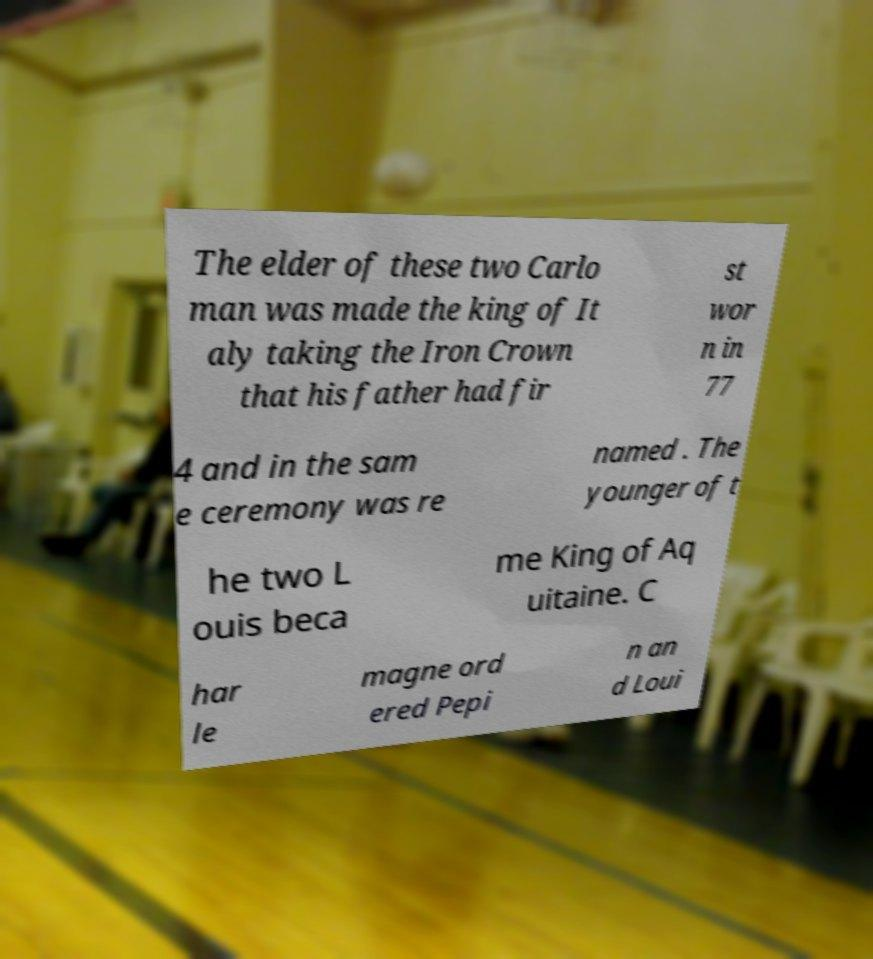Could you assist in decoding the text presented in this image and type it out clearly? The elder of these two Carlo man was made the king of It aly taking the Iron Crown that his father had fir st wor n in 77 4 and in the sam e ceremony was re named . The younger of t he two L ouis beca me King of Aq uitaine. C har le magne ord ered Pepi n an d Loui 